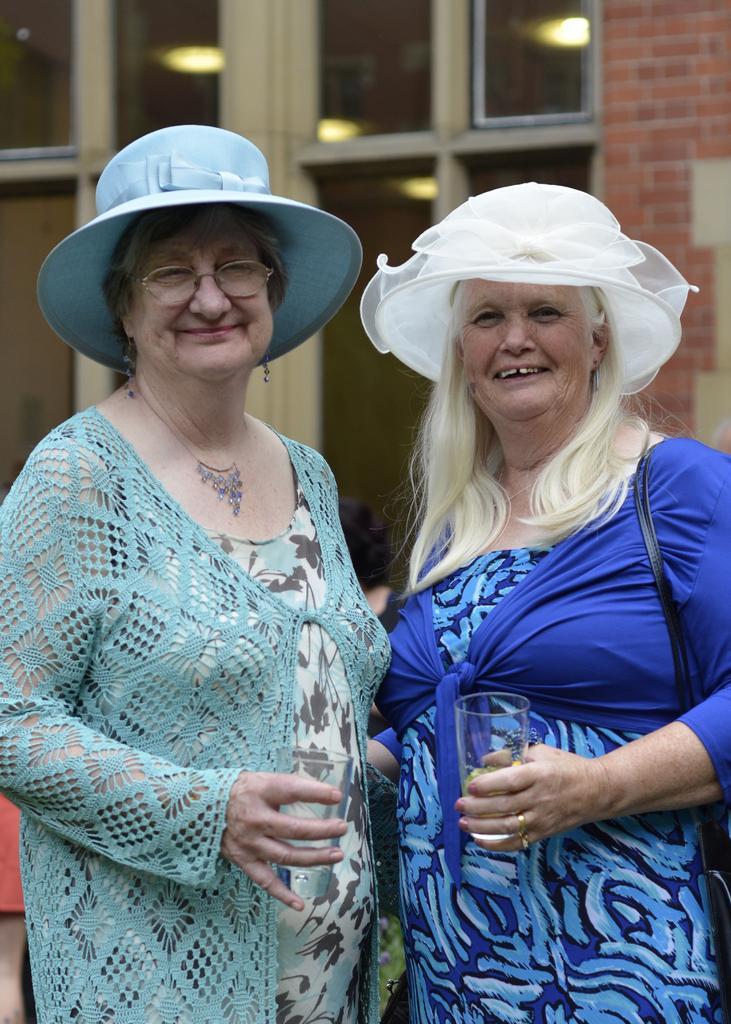Please provide a concise description of this image. This image consists of two women. They are holding glasses. They are wearing hats. 